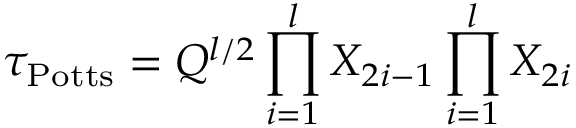<formula> <loc_0><loc_0><loc_500><loc_500>\tau _ { P o t t s } = Q ^ { l / 2 } \prod _ { i = 1 } ^ { l } X _ { 2 i - 1 } \prod _ { i = 1 } ^ { l } X _ { 2 i }</formula> 